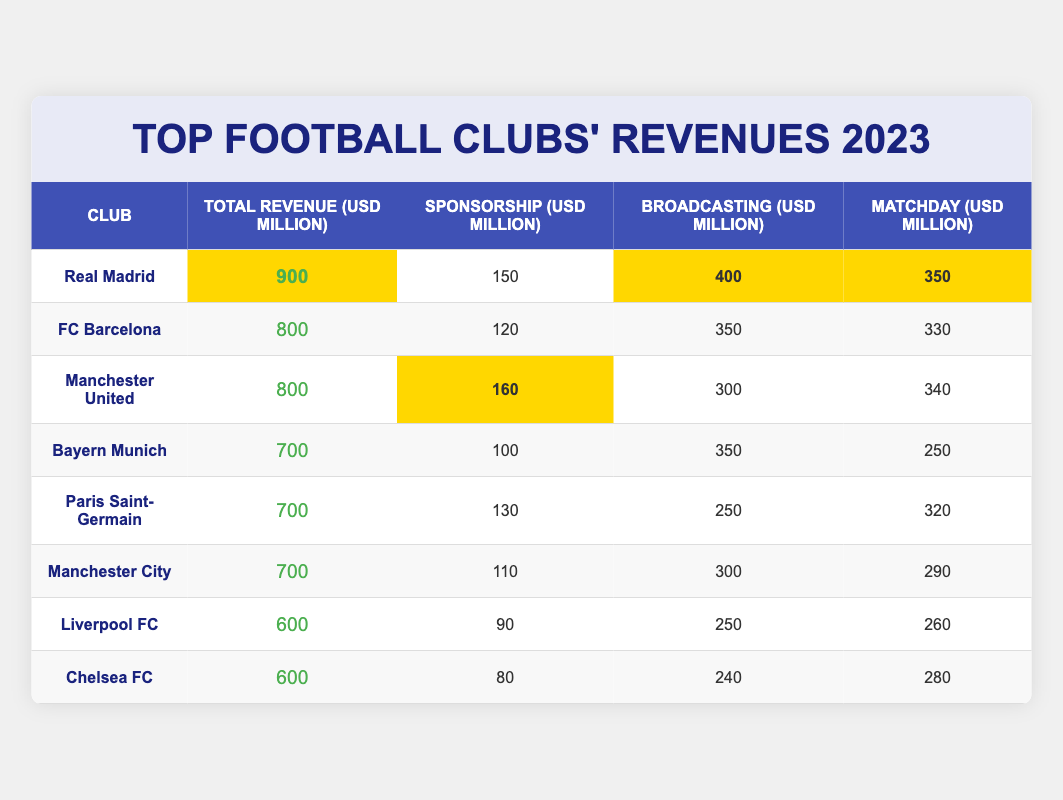What's the total revenue of Manchester United? According to the table, the total revenue for Manchester United is listed as 800 million USD.
Answer: 800 million USD Which club has the highest matchday revenue? The club with the highest matchday revenue is Real Madrid, with 350 million USD.
Answer: Real Madrid What is the total revenue of FC Barcelona and Manchester City combined? The total revenue for FC Barcelona is 800 million USD and for Manchester City, it's 700 million USD. Combining them gives 800 + 700 = 1500 million USD.
Answer: 1500 million USD Is Liverpool FC's sponsorship revenue lower than that of Chelsea FC? Liverpool FC has a sponsorship revenue of 90 million USD, while Chelsea FC has 80 million USD. Therefore, Liverpool FC's sponsorship revenue is higher than Chelsea FC's.
Answer: No What percentage of Real Madrid's total revenue comes from broadcasting? Real Madrid's total revenue is 900 million USD, and their broadcasting revenue is 400 million USD. The percentage is calculated as (400/900) * 100, which equals approximately 44.44%.
Answer: 44.44% Which two clubs have the same total revenue, and what is this revenue? Both FC Barcelona and Manchester United have a total revenue of 800 million USD.
Answer: 800 million USD What is the average matchday revenue of the top three clubs by total revenue? The top three clubs by total revenue are Real Madrid (350 million USD), FC Barcelona (330 million USD), and Manchester United (340 million USD). To find the average, sum their matchday revenues: 350 + 330 + 340 = 1020 million USD, and then divide by 3, giving an average of 340 million USD.
Answer: 340 million USD Which club has the lowest total revenue, and how much is it? The club with the lowest total revenue is Chelsea FC, which has a total revenue of 600 million USD.
Answer: Chelsea FC, 600 million USD Is the sum of sponsorship revenues for Bayern Munich and Paris Saint-Germain greater than the sum of matchday revenues for Liverpool FC and Chelsea FC? Bayern Munich's sponsorship revenue is 100 million USD and Paris Saint-Germain's is 130 million USD, summing to 230 million USD. Liverpool FC's matchday revenue is 260 million USD and Chelsea FC's is 280 million USD, summing to 540 million USD. Since 230 million USD is less than 540 million USD, the answer is no.
Answer: No What is the total revenue of all clubs presented in the table? To find the total revenue, add all clubs' revenues: 900 + 800 + 800 + 700 + 600 + 700 + 600 + 700 = 5100 million USD.
Answer: 5100 million USD 